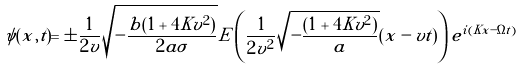<formula> <loc_0><loc_0><loc_500><loc_500>\psi ( x , t ) = \pm \frac { 1 } { 2 v } \sqrt { - \frac { b ( 1 + 4 K v ^ { 2 } ) } { 2 a \sigma } } E \left ( \frac { 1 } { 2 v ^ { 2 } } \sqrt { - \frac { ( 1 + 4 K v ^ { 2 } ) } { a } } ( x - v t ) \right ) e ^ { i ( K x - \Omega t ) }</formula> 